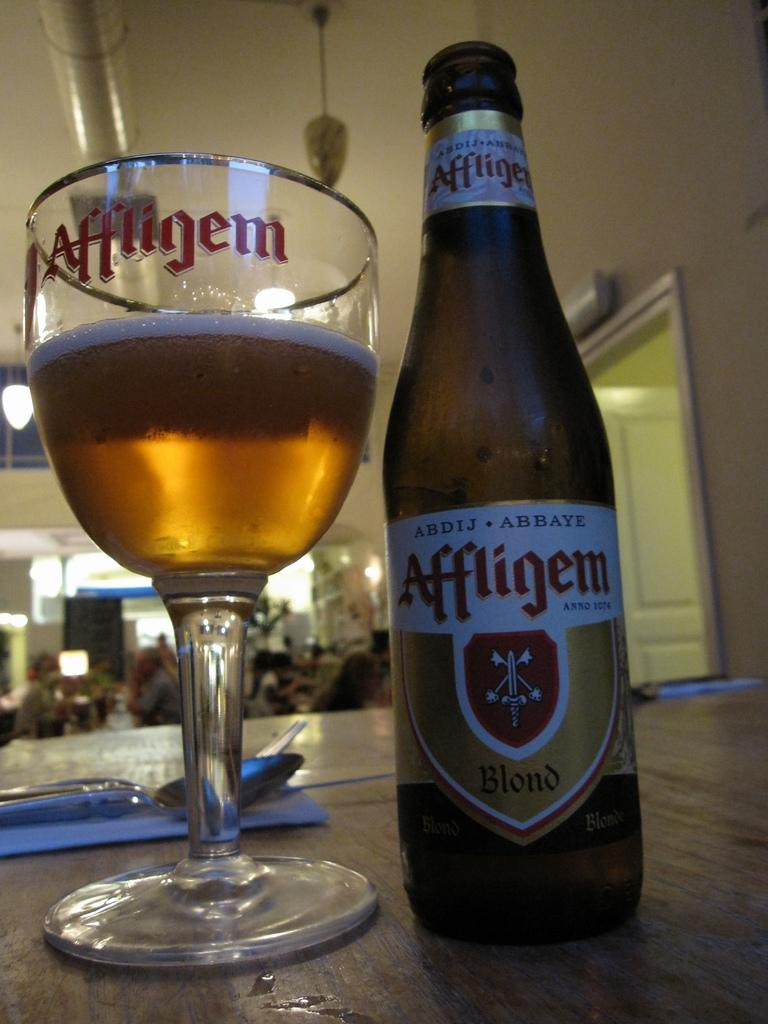What piece of furniture is present in the image? There is a table in the image. What objects are on the table? There is a bottle and a glass on the table. How many ladybugs are crawling on the table in the image? There are no ladybugs present in the image. What songs are being played in the background of the image? There is no information about any songs being played in the image. 